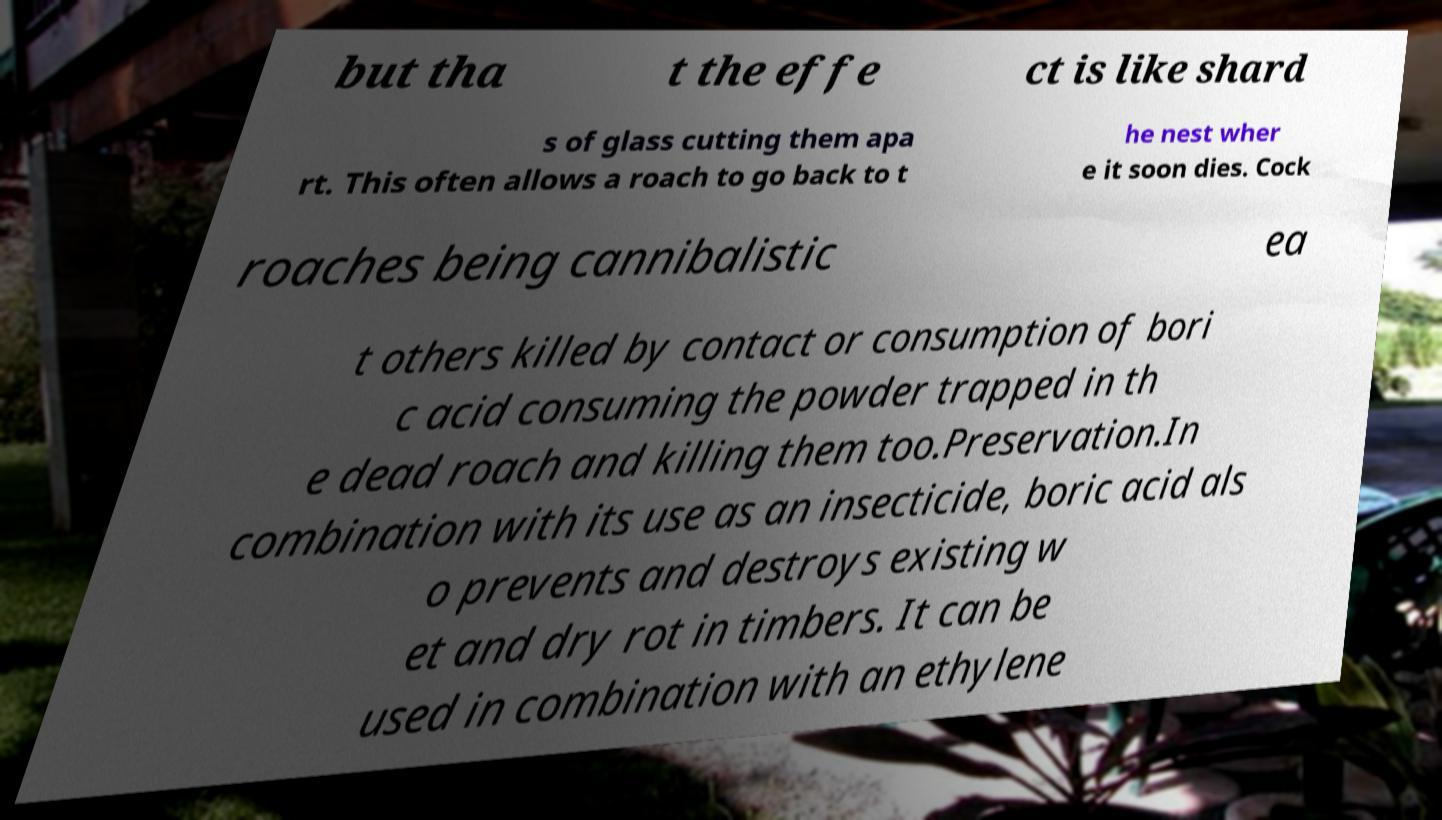Can you accurately transcribe the text from the provided image for me? but tha t the effe ct is like shard s of glass cutting them apa rt. This often allows a roach to go back to t he nest wher e it soon dies. Cock roaches being cannibalistic ea t others killed by contact or consumption of bori c acid consuming the powder trapped in th e dead roach and killing them too.Preservation.In combination with its use as an insecticide, boric acid als o prevents and destroys existing w et and dry rot in timbers. It can be used in combination with an ethylene 